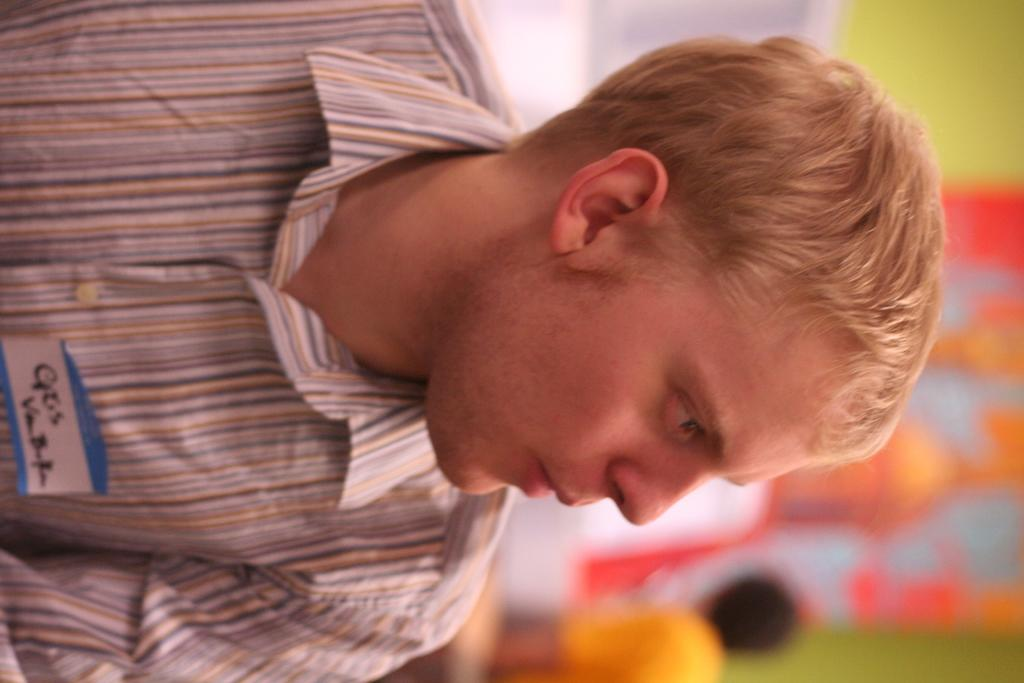What is the main subject of the image? There is a person in the image. What else can be seen in the image besides the person? There is written text on a paper at the bottom of the image. Can you describe the background of the image? The background of the image is blurred. How much payment is being made to the crow in the image? There is no crow present in the image, and therefore no payment can be made to it. 